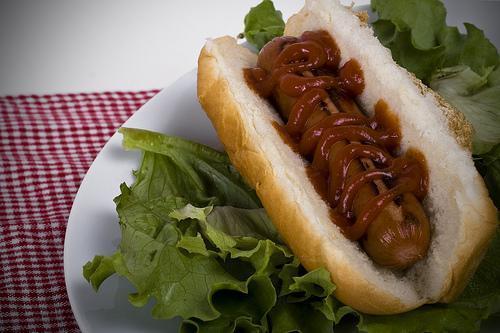How many hot dogs are in the photo?
Give a very brief answer. 1. 